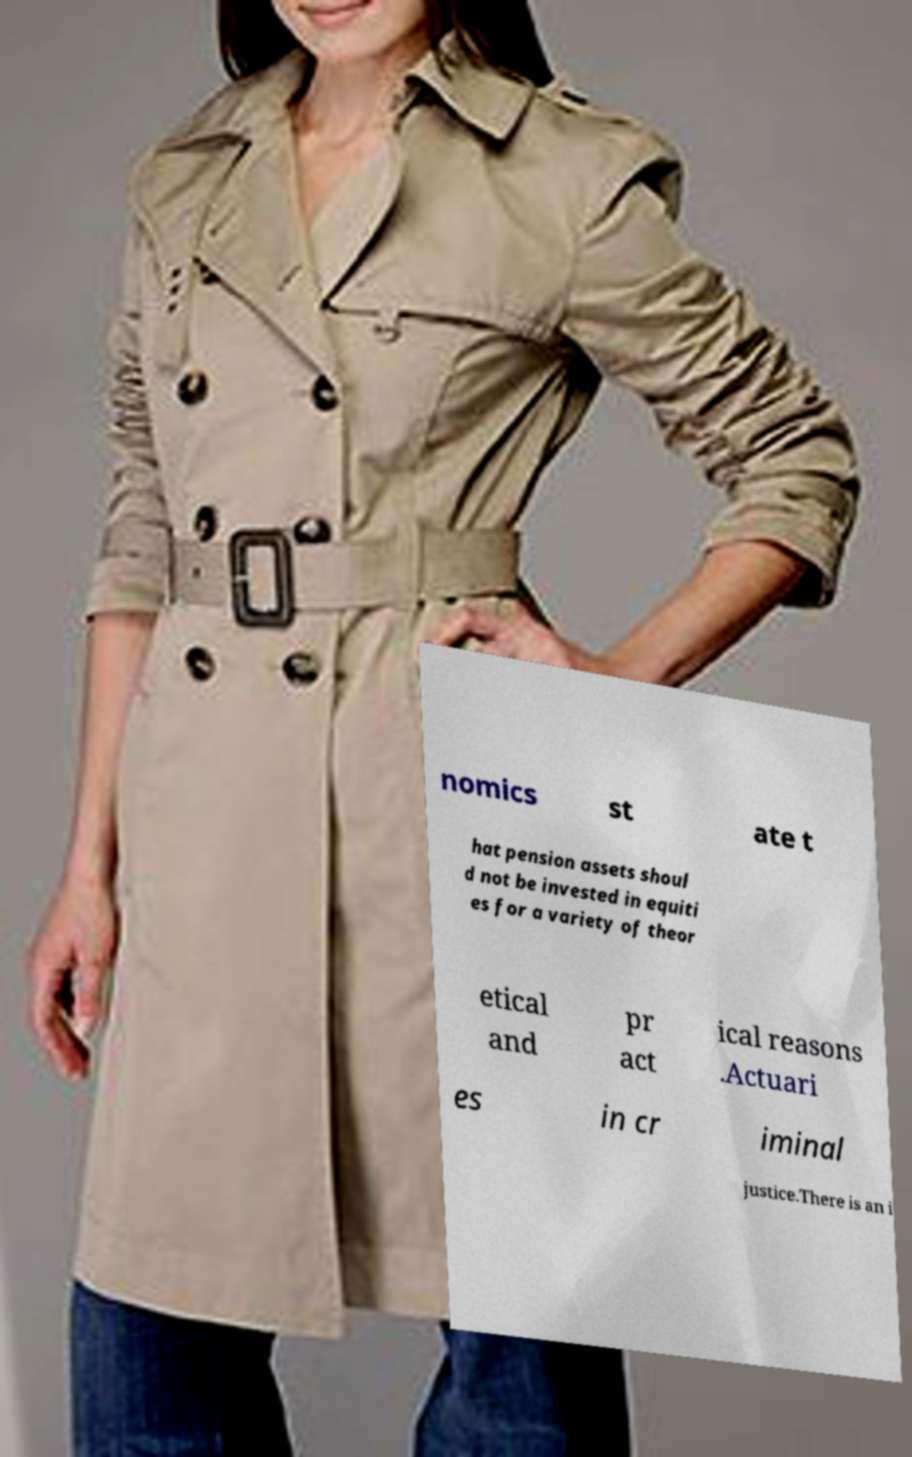Could you assist in decoding the text presented in this image and type it out clearly? nomics st ate t hat pension assets shoul d not be invested in equiti es for a variety of theor etical and pr act ical reasons .Actuari es in cr iminal justice.There is an i 